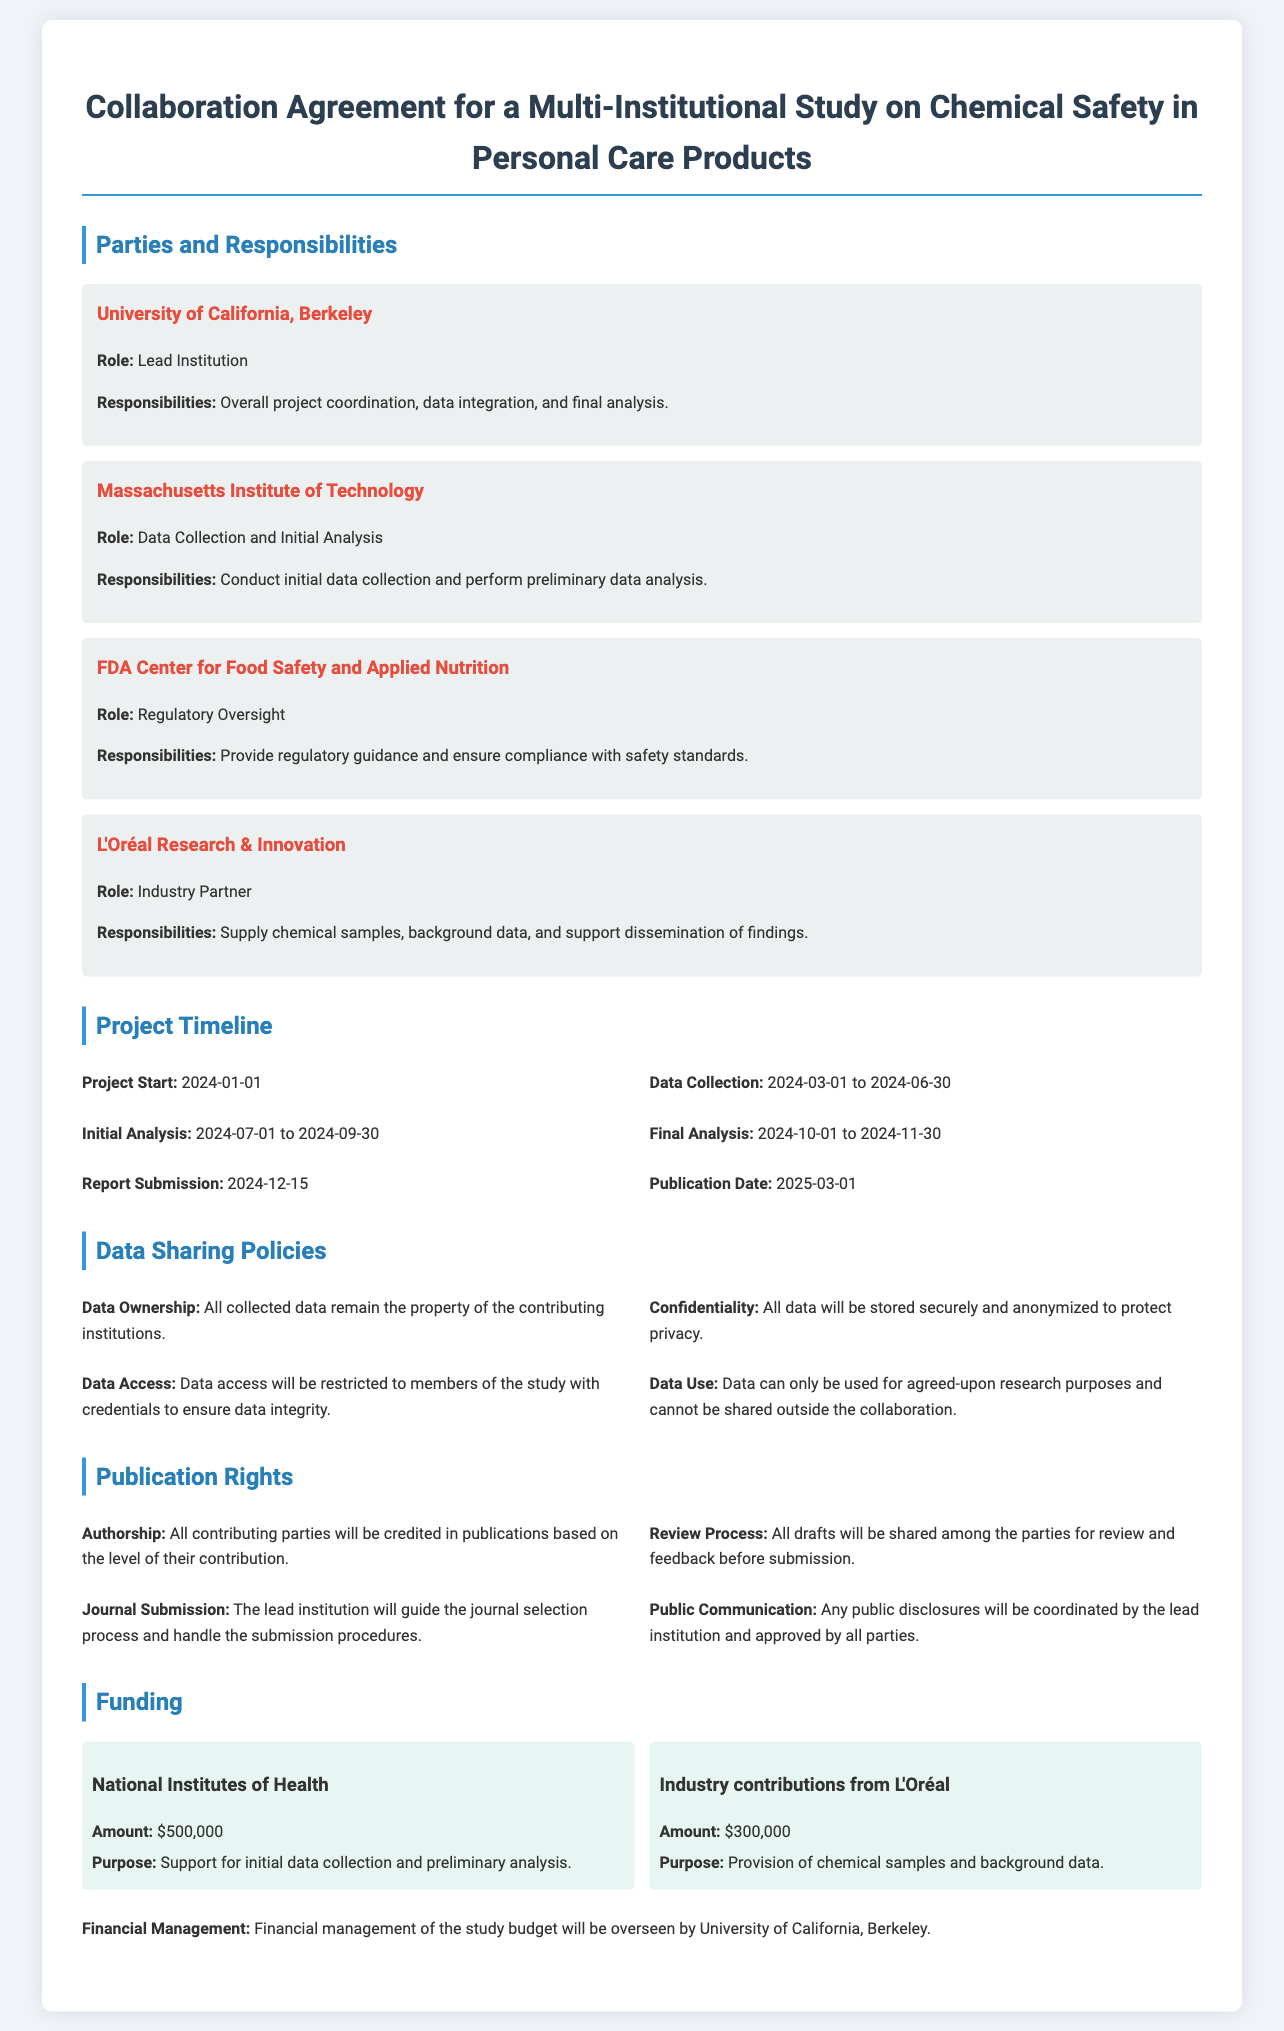What is the lead institution? The lead institution is the one responsible for overall project coordination, as stated in the document.
Answer: University of California, Berkeley What is the duration for data collection? The document specifies the timeframe for data collection, which ranges from the start date to completion.
Answer: 2024-03-01 to 2024-06-30 Who provides regulatory oversight? The role of regulatory oversight is assigned to a specific party mentioned in the contract.
Answer: FDA Center for Food Safety and Applied Nutrition When is the report submission date? The report submission date is explicitly stated in the project timeline section of the document.
Answer: 2024-12-15 How much funding is provided by the National Institutes of Health? This funding source and the amount are outlined in the funding section of the document.
Answer: $500,000 What will the lead institution guide during the publication process? The document mentions the role of the lead institution in managing the publication process.
Answer: Journal selection process What is required before submission of drafts for publication? There is a process of review stated in the publication rights section prior to submission.
Answer: Feedback from all parties What is the purpose of industry contributions from L'Oréal? The document states the specific use of the funds provided by this industry partner.
Answer: Provision of chemical samples and background data 